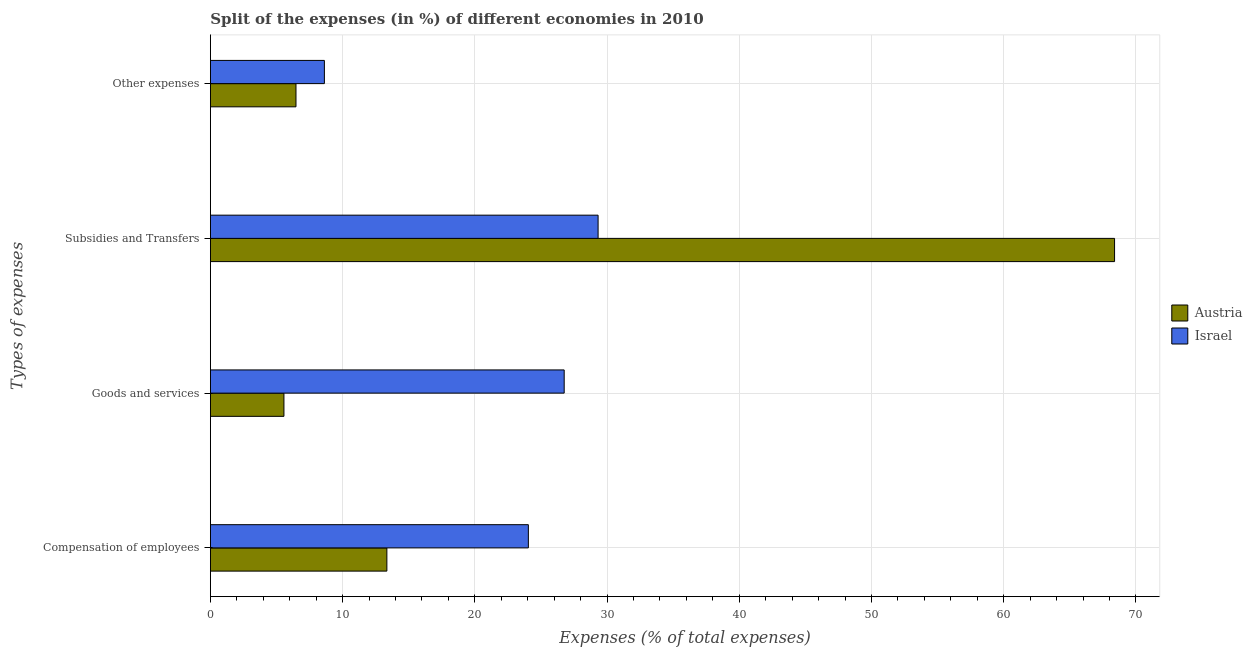How many different coloured bars are there?
Your answer should be compact. 2. How many groups of bars are there?
Make the answer very short. 4. Are the number of bars per tick equal to the number of legend labels?
Offer a very short reply. Yes. Are the number of bars on each tick of the Y-axis equal?
Provide a short and direct response. Yes. How many bars are there on the 1st tick from the top?
Give a very brief answer. 2. What is the label of the 4th group of bars from the top?
Make the answer very short. Compensation of employees. What is the percentage of amount spent on goods and services in Israel?
Your answer should be very brief. 26.76. Across all countries, what is the maximum percentage of amount spent on subsidies?
Your answer should be very brief. 68.38. Across all countries, what is the minimum percentage of amount spent on subsidies?
Ensure brevity in your answer.  29.32. What is the total percentage of amount spent on other expenses in the graph?
Offer a very short reply. 15.1. What is the difference between the percentage of amount spent on other expenses in Austria and that in Israel?
Provide a succinct answer. -2.15. What is the difference between the percentage of amount spent on subsidies in Austria and the percentage of amount spent on compensation of employees in Israel?
Your answer should be compact. 44.33. What is the average percentage of amount spent on other expenses per country?
Your answer should be very brief. 7.55. What is the difference between the percentage of amount spent on other expenses and percentage of amount spent on compensation of employees in Israel?
Make the answer very short. -15.43. What is the ratio of the percentage of amount spent on subsidies in Israel to that in Austria?
Provide a short and direct response. 0.43. Is the difference between the percentage of amount spent on subsidies in Austria and Israel greater than the difference between the percentage of amount spent on goods and services in Austria and Israel?
Provide a succinct answer. Yes. What is the difference between the highest and the second highest percentage of amount spent on other expenses?
Offer a terse response. 2.15. What is the difference between the highest and the lowest percentage of amount spent on subsidies?
Your response must be concise. 39.06. In how many countries, is the percentage of amount spent on subsidies greater than the average percentage of amount spent on subsidies taken over all countries?
Your answer should be very brief. 1. What does the 2nd bar from the bottom in Other expenses represents?
Offer a very short reply. Israel. How many countries are there in the graph?
Make the answer very short. 2. Does the graph contain any zero values?
Your answer should be very brief. No. Does the graph contain grids?
Make the answer very short. Yes. Where does the legend appear in the graph?
Keep it short and to the point. Center right. How many legend labels are there?
Your answer should be compact. 2. How are the legend labels stacked?
Your response must be concise. Vertical. What is the title of the graph?
Your answer should be compact. Split of the expenses (in %) of different economies in 2010. Does "Korea (Democratic)" appear as one of the legend labels in the graph?
Your answer should be very brief. No. What is the label or title of the X-axis?
Make the answer very short. Expenses (% of total expenses). What is the label or title of the Y-axis?
Provide a succinct answer. Types of expenses. What is the Expenses (% of total expenses) in Austria in Compensation of employees?
Provide a short and direct response. 13.35. What is the Expenses (% of total expenses) of Israel in Compensation of employees?
Provide a short and direct response. 24.05. What is the Expenses (% of total expenses) of Austria in Goods and services?
Offer a terse response. 5.56. What is the Expenses (% of total expenses) of Israel in Goods and services?
Offer a terse response. 26.76. What is the Expenses (% of total expenses) in Austria in Subsidies and Transfers?
Give a very brief answer. 68.38. What is the Expenses (% of total expenses) in Israel in Subsidies and Transfers?
Your answer should be compact. 29.32. What is the Expenses (% of total expenses) in Austria in Other expenses?
Your response must be concise. 6.47. What is the Expenses (% of total expenses) in Israel in Other expenses?
Provide a short and direct response. 8.62. Across all Types of expenses, what is the maximum Expenses (% of total expenses) of Austria?
Offer a terse response. 68.38. Across all Types of expenses, what is the maximum Expenses (% of total expenses) of Israel?
Make the answer very short. 29.32. Across all Types of expenses, what is the minimum Expenses (% of total expenses) of Austria?
Your answer should be compact. 5.56. Across all Types of expenses, what is the minimum Expenses (% of total expenses) of Israel?
Provide a short and direct response. 8.62. What is the total Expenses (% of total expenses) in Austria in the graph?
Your answer should be compact. 93.77. What is the total Expenses (% of total expenses) in Israel in the graph?
Offer a terse response. 88.75. What is the difference between the Expenses (% of total expenses) of Austria in Compensation of employees and that in Goods and services?
Give a very brief answer. 7.78. What is the difference between the Expenses (% of total expenses) in Israel in Compensation of employees and that in Goods and services?
Your answer should be compact. -2.71. What is the difference between the Expenses (% of total expenses) of Austria in Compensation of employees and that in Subsidies and Transfers?
Keep it short and to the point. -55.04. What is the difference between the Expenses (% of total expenses) in Israel in Compensation of employees and that in Subsidies and Transfers?
Offer a very short reply. -5.27. What is the difference between the Expenses (% of total expenses) in Austria in Compensation of employees and that in Other expenses?
Give a very brief answer. 6.87. What is the difference between the Expenses (% of total expenses) of Israel in Compensation of employees and that in Other expenses?
Your response must be concise. 15.43. What is the difference between the Expenses (% of total expenses) of Austria in Goods and services and that in Subsidies and Transfers?
Your answer should be very brief. -62.82. What is the difference between the Expenses (% of total expenses) of Israel in Goods and services and that in Subsidies and Transfers?
Your answer should be compact. -2.56. What is the difference between the Expenses (% of total expenses) of Austria in Goods and services and that in Other expenses?
Your response must be concise. -0.91. What is the difference between the Expenses (% of total expenses) in Israel in Goods and services and that in Other expenses?
Your response must be concise. 18.14. What is the difference between the Expenses (% of total expenses) in Austria in Subsidies and Transfers and that in Other expenses?
Your response must be concise. 61.91. What is the difference between the Expenses (% of total expenses) in Israel in Subsidies and Transfers and that in Other expenses?
Offer a terse response. 20.7. What is the difference between the Expenses (% of total expenses) of Austria in Compensation of employees and the Expenses (% of total expenses) of Israel in Goods and services?
Give a very brief answer. -13.41. What is the difference between the Expenses (% of total expenses) in Austria in Compensation of employees and the Expenses (% of total expenses) in Israel in Subsidies and Transfers?
Ensure brevity in your answer.  -15.97. What is the difference between the Expenses (% of total expenses) in Austria in Compensation of employees and the Expenses (% of total expenses) in Israel in Other expenses?
Make the answer very short. 4.72. What is the difference between the Expenses (% of total expenses) of Austria in Goods and services and the Expenses (% of total expenses) of Israel in Subsidies and Transfers?
Your answer should be compact. -23.76. What is the difference between the Expenses (% of total expenses) of Austria in Goods and services and the Expenses (% of total expenses) of Israel in Other expenses?
Keep it short and to the point. -3.06. What is the difference between the Expenses (% of total expenses) of Austria in Subsidies and Transfers and the Expenses (% of total expenses) of Israel in Other expenses?
Keep it short and to the point. 59.76. What is the average Expenses (% of total expenses) in Austria per Types of expenses?
Ensure brevity in your answer.  23.44. What is the average Expenses (% of total expenses) in Israel per Types of expenses?
Offer a very short reply. 22.19. What is the difference between the Expenses (% of total expenses) of Austria and Expenses (% of total expenses) of Israel in Compensation of employees?
Provide a succinct answer. -10.7. What is the difference between the Expenses (% of total expenses) in Austria and Expenses (% of total expenses) in Israel in Goods and services?
Ensure brevity in your answer.  -21.2. What is the difference between the Expenses (% of total expenses) in Austria and Expenses (% of total expenses) in Israel in Subsidies and Transfers?
Your answer should be very brief. 39.06. What is the difference between the Expenses (% of total expenses) in Austria and Expenses (% of total expenses) in Israel in Other expenses?
Give a very brief answer. -2.15. What is the ratio of the Expenses (% of total expenses) of Austria in Compensation of employees to that in Goods and services?
Ensure brevity in your answer.  2.4. What is the ratio of the Expenses (% of total expenses) of Israel in Compensation of employees to that in Goods and services?
Make the answer very short. 0.9. What is the ratio of the Expenses (% of total expenses) in Austria in Compensation of employees to that in Subsidies and Transfers?
Your answer should be very brief. 0.2. What is the ratio of the Expenses (% of total expenses) in Israel in Compensation of employees to that in Subsidies and Transfers?
Provide a succinct answer. 0.82. What is the ratio of the Expenses (% of total expenses) in Austria in Compensation of employees to that in Other expenses?
Provide a short and direct response. 2.06. What is the ratio of the Expenses (% of total expenses) in Israel in Compensation of employees to that in Other expenses?
Your response must be concise. 2.79. What is the ratio of the Expenses (% of total expenses) in Austria in Goods and services to that in Subsidies and Transfers?
Your answer should be compact. 0.08. What is the ratio of the Expenses (% of total expenses) of Israel in Goods and services to that in Subsidies and Transfers?
Provide a succinct answer. 0.91. What is the ratio of the Expenses (% of total expenses) in Austria in Goods and services to that in Other expenses?
Give a very brief answer. 0.86. What is the ratio of the Expenses (% of total expenses) in Israel in Goods and services to that in Other expenses?
Provide a succinct answer. 3.1. What is the ratio of the Expenses (% of total expenses) of Austria in Subsidies and Transfers to that in Other expenses?
Offer a very short reply. 10.56. What is the ratio of the Expenses (% of total expenses) of Israel in Subsidies and Transfers to that in Other expenses?
Your answer should be very brief. 3.4. What is the difference between the highest and the second highest Expenses (% of total expenses) of Austria?
Ensure brevity in your answer.  55.04. What is the difference between the highest and the second highest Expenses (% of total expenses) of Israel?
Offer a very short reply. 2.56. What is the difference between the highest and the lowest Expenses (% of total expenses) in Austria?
Ensure brevity in your answer.  62.82. What is the difference between the highest and the lowest Expenses (% of total expenses) in Israel?
Make the answer very short. 20.7. 